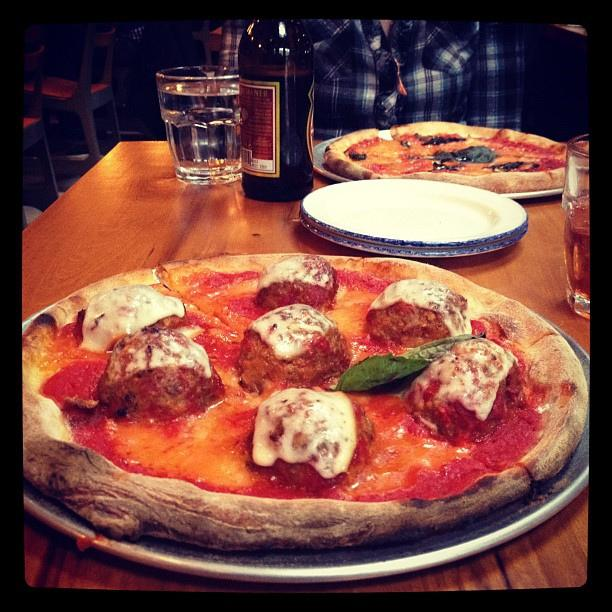The two pizzas have different sized what? toppings 